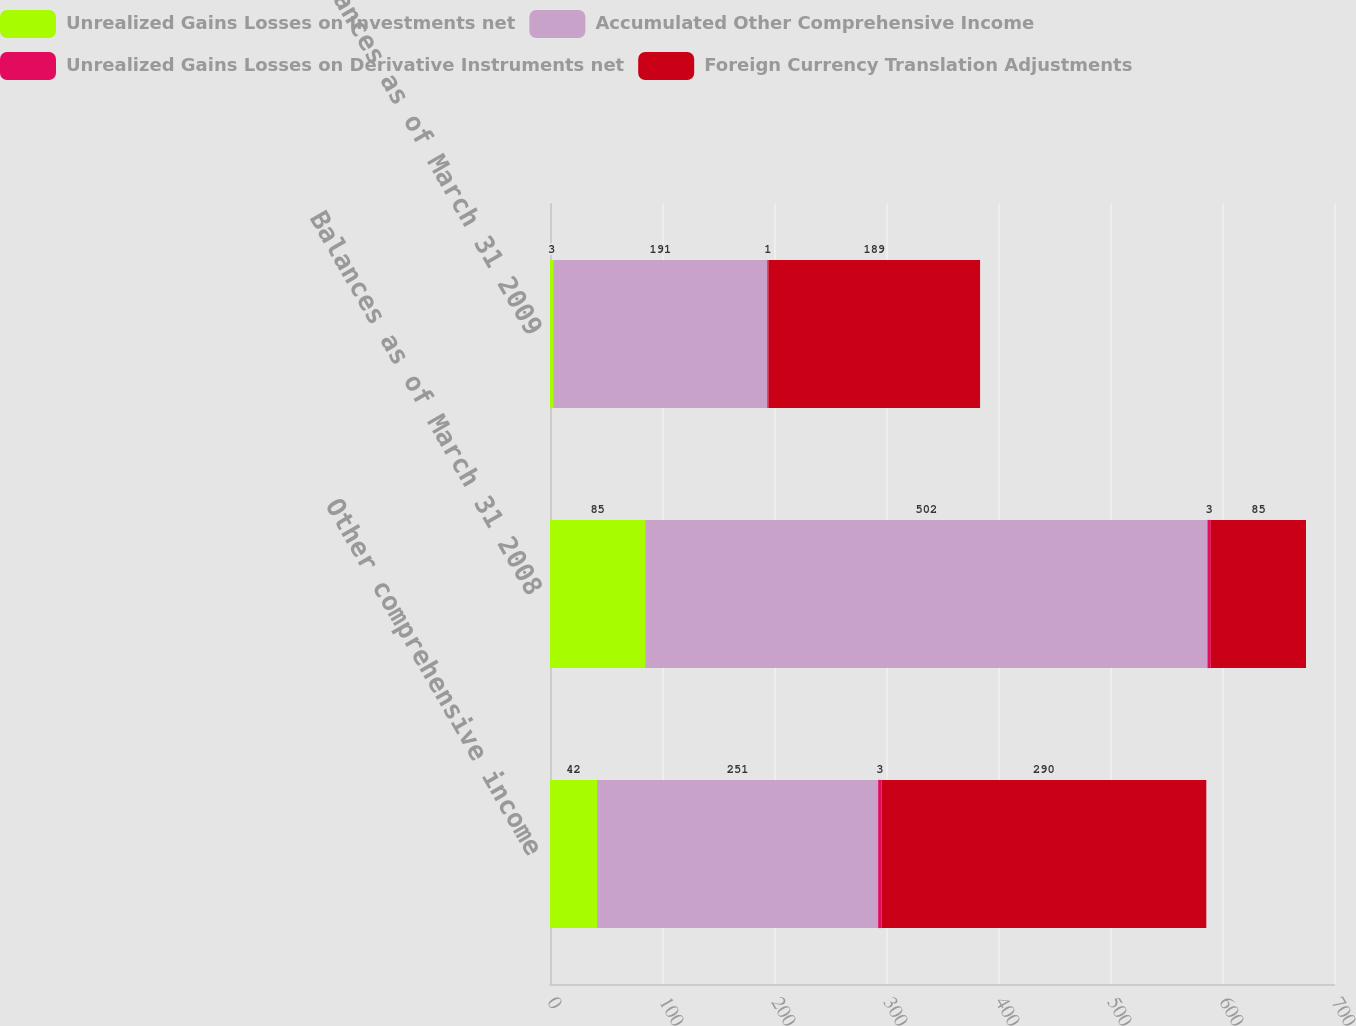Convert chart. <chart><loc_0><loc_0><loc_500><loc_500><stacked_bar_chart><ecel><fcel>Other comprehensive income<fcel>Balances as of March 31 2008<fcel>Balances as of March 31 2009<nl><fcel>Unrealized Gains Losses on Investments net<fcel>42<fcel>85<fcel>3<nl><fcel>Accumulated Other Comprehensive Income<fcel>251<fcel>502<fcel>191<nl><fcel>Unrealized Gains Losses on Derivative Instruments net<fcel>3<fcel>3<fcel>1<nl><fcel>Foreign Currency Translation Adjustments<fcel>290<fcel>85<fcel>189<nl></chart> 